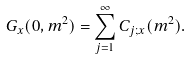Convert formula to latex. <formula><loc_0><loc_0><loc_500><loc_500>G _ { x } ( 0 , m ^ { 2 } ) = \sum _ { j = 1 } ^ { \infty } C _ { j ; x } ( m ^ { 2 } ) .</formula> 